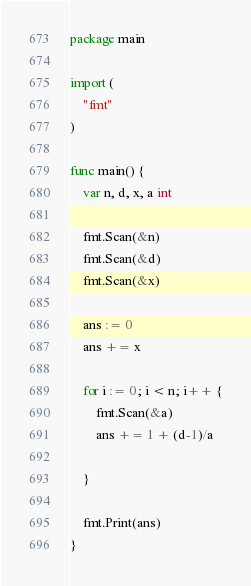<code> <loc_0><loc_0><loc_500><loc_500><_Go_>package main

import (
	"fmt"
)

func main() {
	var n, d, x, a int

	fmt.Scan(&n)
	fmt.Scan(&d)
	fmt.Scan(&x)

	ans := 0
	ans += x

	for i := 0; i < n; i++ {
		fmt.Scan(&a)
		ans += 1 + (d-1)/a

	}

	fmt.Print(ans)
}</code> 